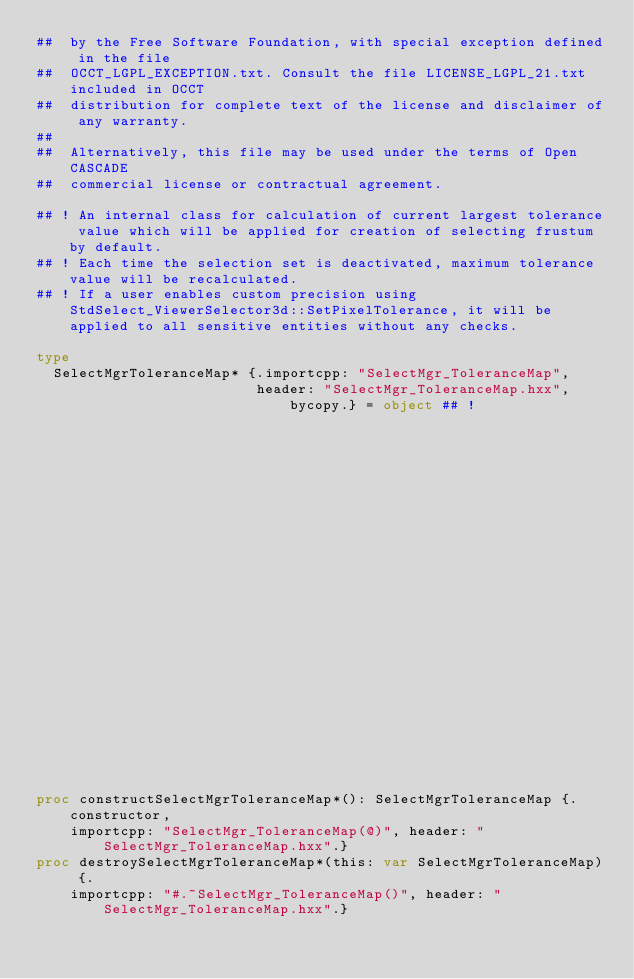Convert code to text. <code><loc_0><loc_0><loc_500><loc_500><_Nim_>##  by the Free Software Foundation, with special exception defined in the file
##  OCCT_LGPL_EXCEPTION.txt. Consult the file LICENSE_LGPL_21.txt included in OCCT
##  distribution for complete text of the license and disclaimer of any warranty.
##
##  Alternatively, this file may be used under the terms of Open CASCADE
##  commercial license or contractual agreement.

## ! An internal class for calculation of current largest tolerance value which will be applied for creation of selecting frustum by default.
## ! Each time the selection set is deactivated, maximum tolerance value will be recalculated.
## ! If a user enables custom precision using StdSelect_ViewerSelector3d::SetPixelTolerance, it will be applied to all sensitive entities without any checks.

type
  SelectMgrToleranceMap* {.importcpp: "SelectMgr_ToleranceMap",
                          header: "SelectMgr_ToleranceMap.hxx", bycopy.} = object ## !
                                                                             ## Sets
                                                                             ## tolerance
                                                                             ## values to
                                                                             ## -1.0


proc constructSelectMgrToleranceMap*(): SelectMgrToleranceMap {.constructor,
    importcpp: "SelectMgr_ToleranceMap(@)", header: "SelectMgr_ToleranceMap.hxx".}
proc destroySelectMgrToleranceMap*(this: var SelectMgrToleranceMap) {.
    importcpp: "#.~SelectMgr_ToleranceMap()", header: "SelectMgr_ToleranceMap.hxx".}</code> 